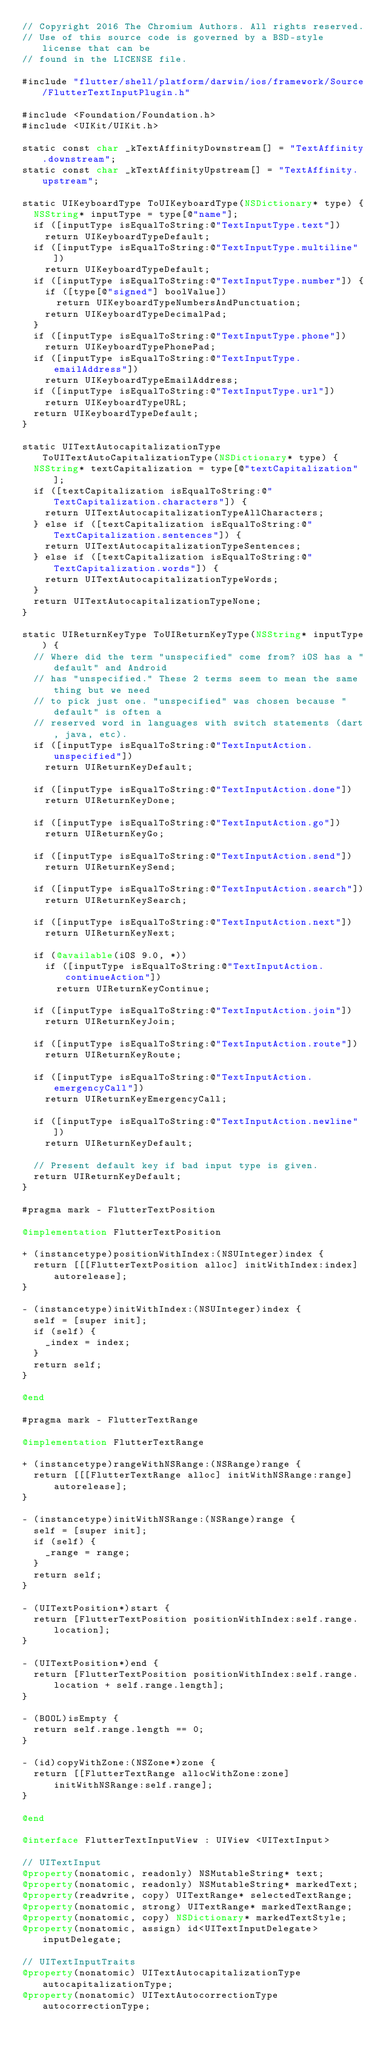Convert code to text. <code><loc_0><loc_0><loc_500><loc_500><_ObjectiveC_>// Copyright 2016 The Chromium Authors. All rights reserved.
// Use of this source code is governed by a BSD-style license that can be
// found in the LICENSE file.

#include "flutter/shell/platform/darwin/ios/framework/Source/FlutterTextInputPlugin.h"

#include <Foundation/Foundation.h>
#include <UIKit/UIKit.h>

static const char _kTextAffinityDownstream[] = "TextAffinity.downstream";
static const char _kTextAffinityUpstream[] = "TextAffinity.upstream";

static UIKeyboardType ToUIKeyboardType(NSDictionary* type) {
  NSString* inputType = type[@"name"];
  if ([inputType isEqualToString:@"TextInputType.text"])
    return UIKeyboardTypeDefault;
  if ([inputType isEqualToString:@"TextInputType.multiline"])
    return UIKeyboardTypeDefault;
  if ([inputType isEqualToString:@"TextInputType.number"]) {
    if ([type[@"signed"] boolValue])
      return UIKeyboardTypeNumbersAndPunctuation;
    return UIKeyboardTypeDecimalPad;
  }
  if ([inputType isEqualToString:@"TextInputType.phone"])
    return UIKeyboardTypePhonePad;
  if ([inputType isEqualToString:@"TextInputType.emailAddress"])
    return UIKeyboardTypeEmailAddress;
  if ([inputType isEqualToString:@"TextInputType.url"])
    return UIKeyboardTypeURL;
  return UIKeyboardTypeDefault;
}

static UITextAutocapitalizationType ToUITextAutoCapitalizationType(NSDictionary* type) {
  NSString* textCapitalization = type[@"textCapitalization"];
  if ([textCapitalization isEqualToString:@"TextCapitalization.characters"]) {
    return UITextAutocapitalizationTypeAllCharacters;
  } else if ([textCapitalization isEqualToString:@"TextCapitalization.sentences"]) {
    return UITextAutocapitalizationTypeSentences;
  } else if ([textCapitalization isEqualToString:@"TextCapitalization.words"]) {
    return UITextAutocapitalizationTypeWords;
  }
  return UITextAutocapitalizationTypeNone;
}

static UIReturnKeyType ToUIReturnKeyType(NSString* inputType) {
  // Where did the term "unspecified" come from? iOS has a "default" and Android
  // has "unspecified." These 2 terms seem to mean the same thing but we need
  // to pick just one. "unspecified" was chosen because "default" is often a
  // reserved word in languages with switch statements (dart, java, etc).
  if ([inputType isEqualToString:@"TextInputAction.unspecified"])
    return UIReturnKeyDefault;

  if ([inputType isEqualToString:@"TextInputAction.done"])
    return UIReturnKeyDone;

  if ([inputType isEqualToString:@"TextInputAction.go"])
    return UIReturnKeyGo;

  if ([inputType isEqualToString:@"TextInputAction.send"])
    return UIReturnKeySend;

  if ([inputType isEqualToString:@"TextInputAction.search"])
    return UIReturnKeySearch;

  if ([inputType isEqualToString:@"TextInputAction.next"])
    return UIReturnKeyNext;

  if (@available(iOS 9.0, *))
    if ([inputType isEqualToString:@"TextInputAction.continueAction"])
      return UIReturnKeyContinue;

  if ([inputType isEqualToString:@"TextInputAction.join"])
    return UIReturnKeyJoin;

  if ([inputType isEqualToString:@"TextInputAction.route"])
    return UIReturnKeyRoute;

  if ([inputType isEqualToString:@"TextInputAction.emergencyCall"])
    return UIReturnKeyEmergencyCall;

  if ([inputType isEqualToString:@"TextInputAction.newline"])
    return UIReturnKeyDefault;

  // Present default key if bad input type is given.
  return UIReturnKeyDefault;
}

#pragma mark - FlutterTextPosition

@implementation FlutterTextPosition

+ (instancetype)positionWithIndex:(NSUInteger)index {
  return [[[FlutterTextPosition alloc] initWithIndex:index] autorelease];
}

- (instancetype)initWithIndex:(NSUInteger)index {
  self = [super init];
  if (self) {
    _index = index;
  }
  return self;
}

@end

#pragma mark - FlutterTextRange

@implementation FlutterTextRange

+ (instancetype)rangeWithNSRange:(NSRange)range {
  return [[[FlutterTextRange alloc] initWithNSRange:range] autorelease];
}

- (instancetype)initWithNSRange:(NSRange)range {
  self = [super init];
  if (self) {
    _range = range;
  }
  return self;
}

- (UITextPosition*)start {
  return [FlutterTextPosition positionWithIndex:self.range.location];
}

- (UITextPosition*)end {
  return [FlutterTextPosition positionWithIndex:self.range.location + self.range.length];
}

- (BOOL)isEmpty {
  return self.range.length == 0;
}

- (id)copyWithZone:(NSZone*)zone {
  return [[FlutterTextRange allocWithZone:zone] initWithNSRange:self.range];
}

@end

@interface FlutterTextInputView : UIView <UITextInput>

// UITextInput
@property(nonatomic, readonly) NSMutableString* text;
@property(nonatomic, readonly) NSMutableString* markedText;
@property(readwrite, copy) UITextRange* selectedTextRange;
@property(nonatomic, strong) UITextRange* markedTextRange;
@property(nonatomic, copy) NSDictionary* markedTextStyle;
@property(nonatomic, assign) id<UITextInputDelegate> inputDelegate;

// UITextInputTraits
@property(nonatomic) UITextAutocapitalizationType autocapitalizationType;
@property(nonatomic) UITextAutocorrectionType autocorrectionType;</code> 